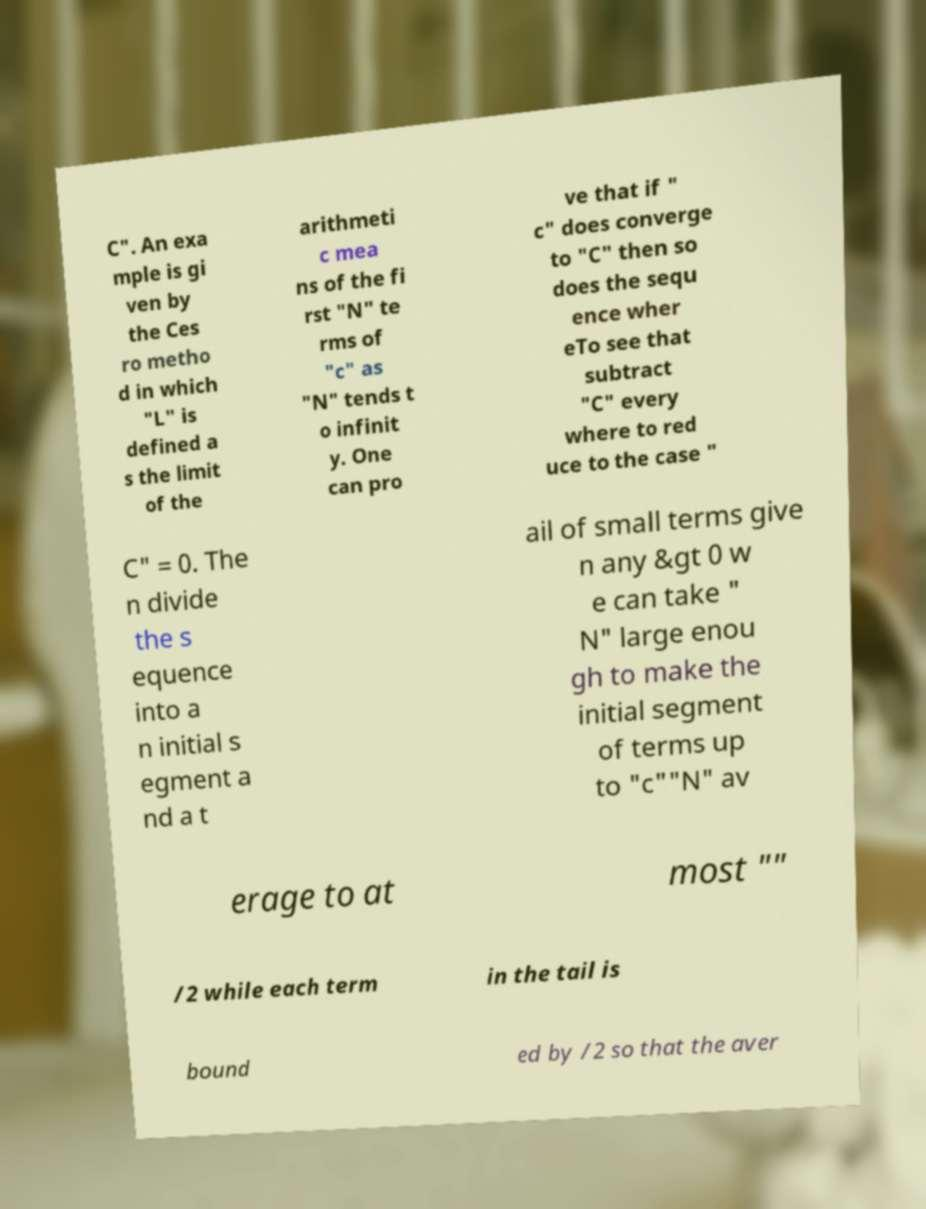Could you extract and type out the text from this image? C". An exa mple is gi ven by the Ces ro metho d in which "L" is defined a s the limit of the arithmeti c mea ns of the fi rst "N" te rms of "c" as "N" tends t o infinit y. One can pro ve that if " c" does converge to "C" then so does the sequ ence wher eTo see that subtract "C" every where to red uce to the case " C" = 0. The n divide the s equence into a n initial s egment a nd a t ail of small terms give n any &gt 0 w e can take " N" large enou gh to make the initial segment of terms up to "c""N" av erage to at most "" /2 while each term in the tail is bound ed by /2 so that the aver 